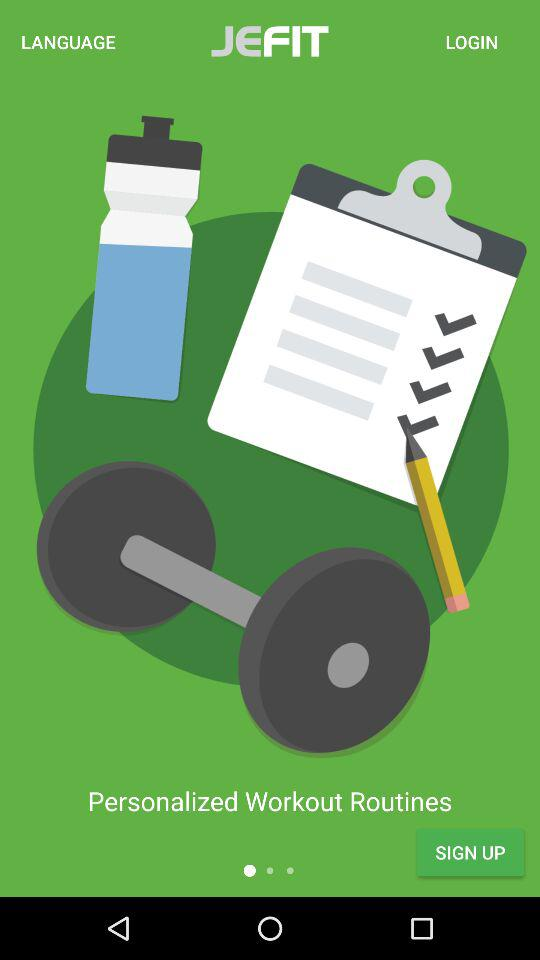Which language is selected for the application?
When the provided information is insufficient, respond with <no answer>. <no answer> 